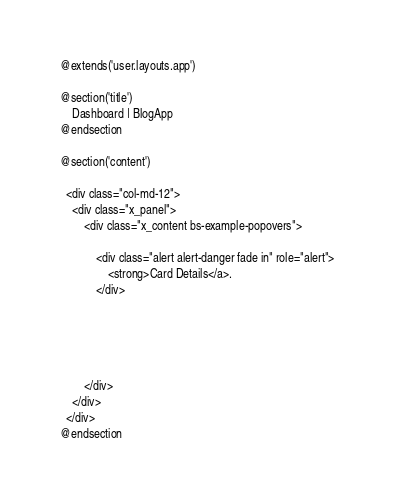<code> <loc_0><loc_0><loc_500><loc_500><_PHP_>@extends('user.layouts.app')

@section('title')
    Dashboard | BlogApp 
@endsection

@section('content')

  <div class="col-md-12">
    <div class="x_panel">
        <div class="x_content bs-example-popovers">

            <div class="alert alert-danger fade in" role="alert">
                <strong>Card Details</a>.
            </div>

             
            
            

        </div>
    </div>
  </div>
@endsection</code> 